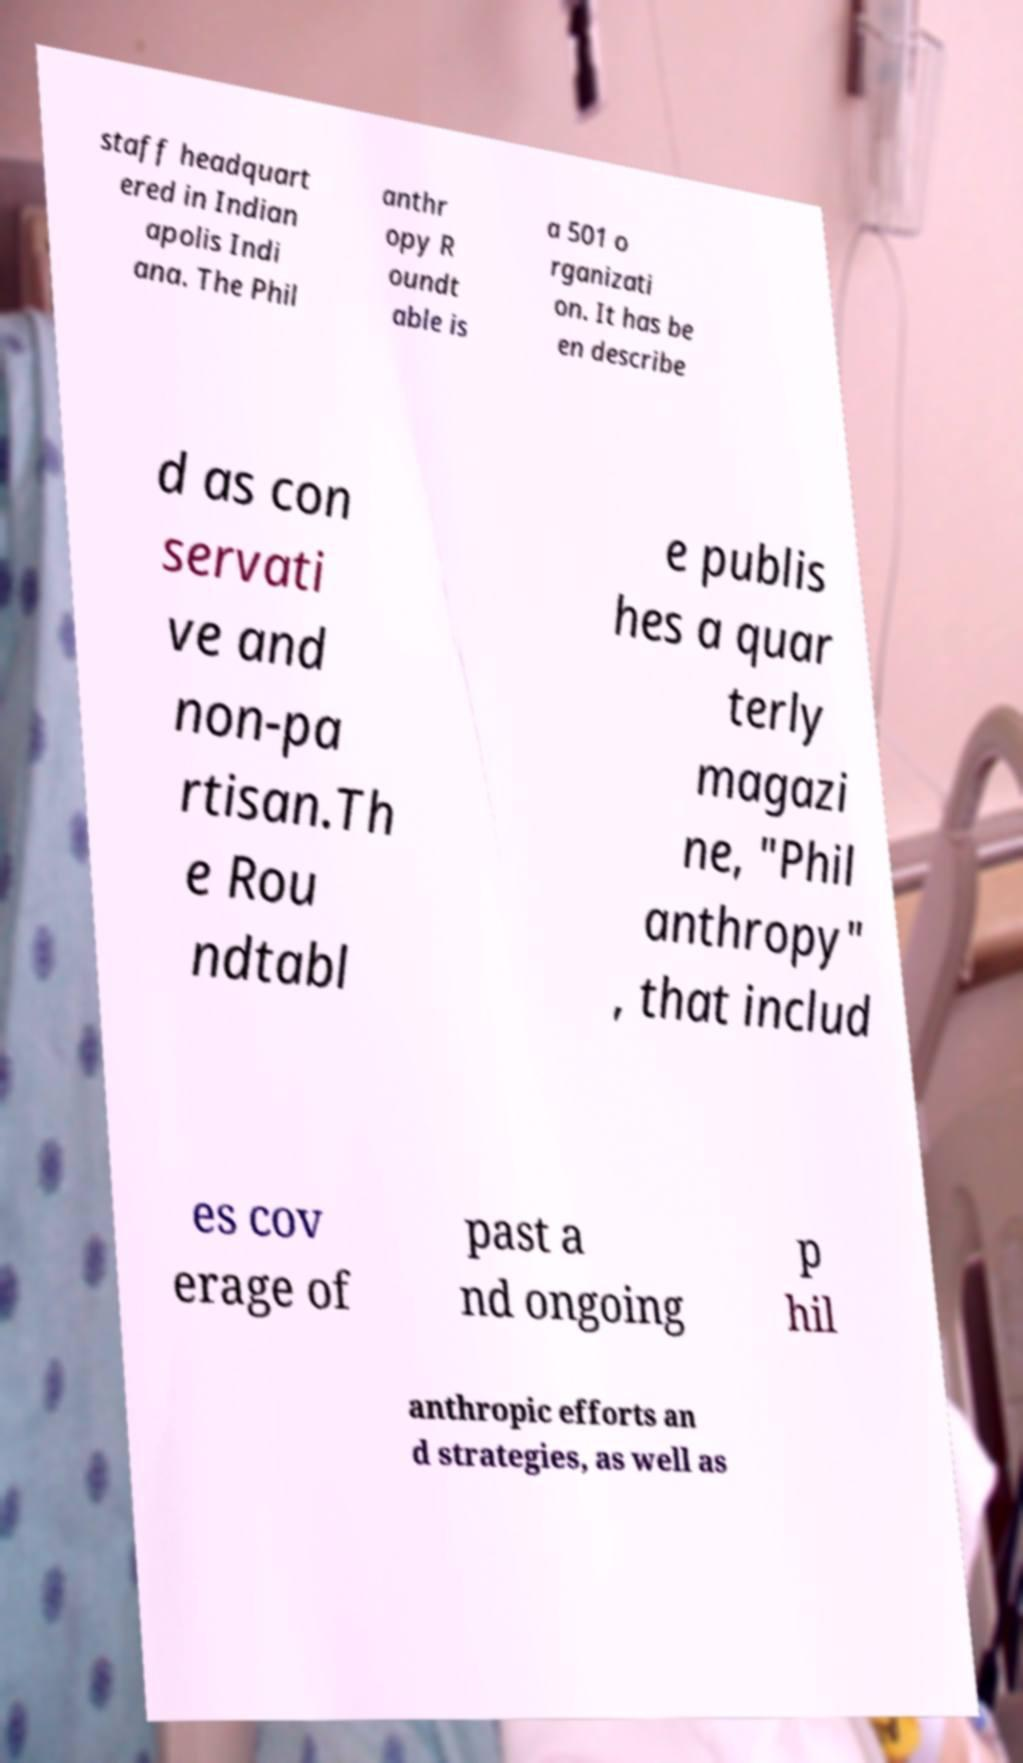Could you assist in decoding the text presented in this image and type it out clearly? staff headquart ered in Indian apolis Indi ana. The Phil anthr opy R oundt able is a 501 o rganizati on. It has be en describe d as con servati ve and non-pa rtisan.Th e Rou ndtabl e publis hes a quar terly magazi ne, "Phil anthropy" , that includ es cov erage of past a nd ongoing p hil anthropic efforts an d strategies, as well as 